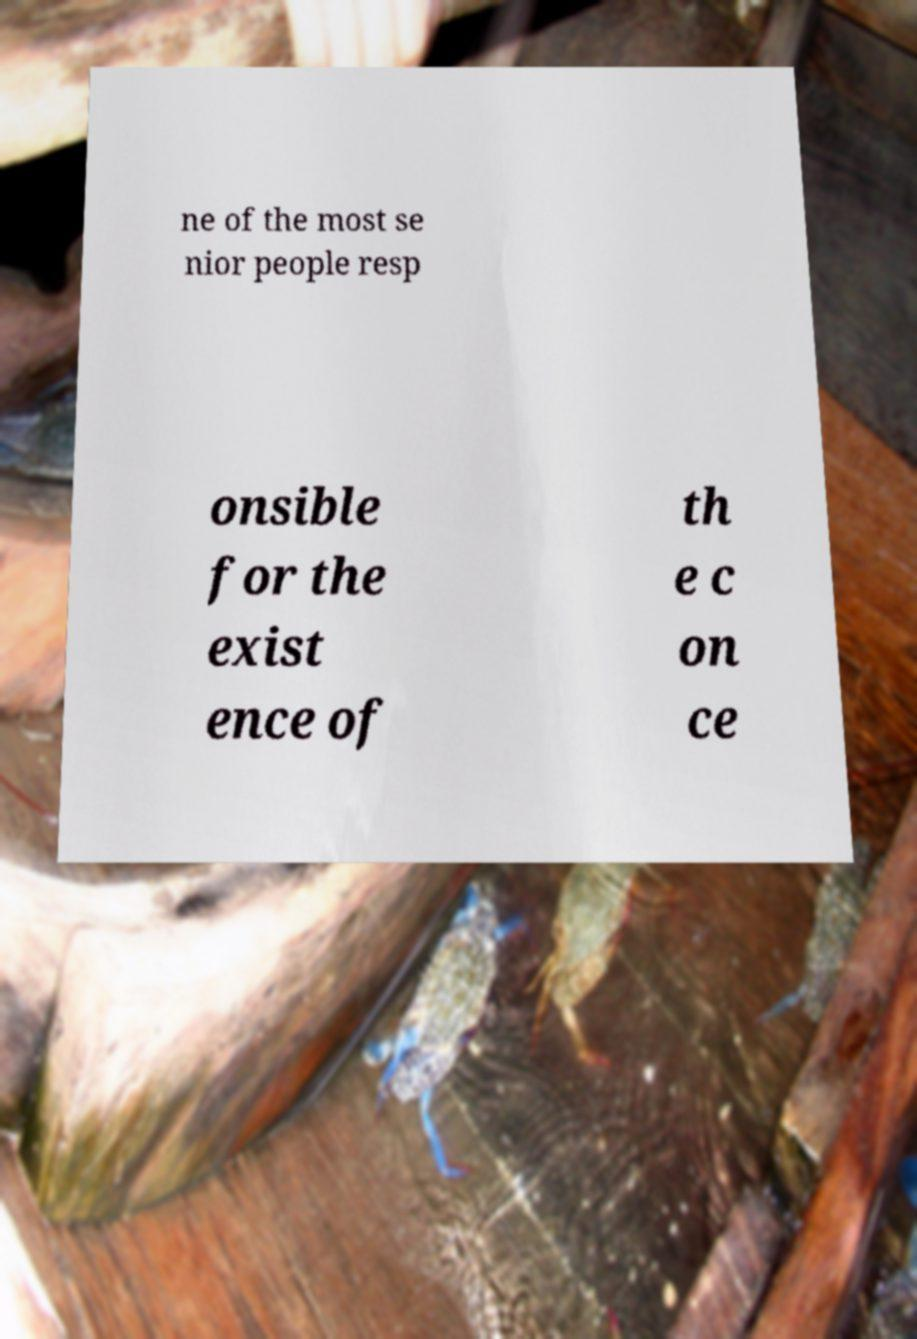Please read and relay the text visible in this image. What does it say? ne of the most se nior people resp onsible for the exist ence of th e c on ce 